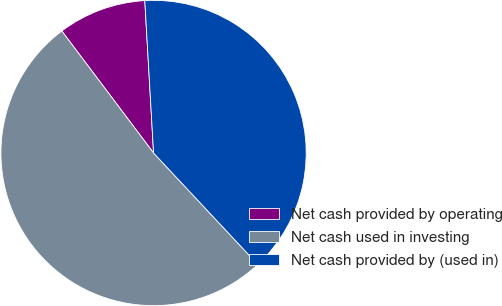Convert chart. <chart><loc_0><loc_0><loc_500><loc_500><pie_chart><fcel>Net cash provided by operating<fcel>Net cash used in investing<fcel>Net cash provided by (used in)<nl><fcel>9.35%<fcel>51.7%<fcel>38.95%<nl></chart> 